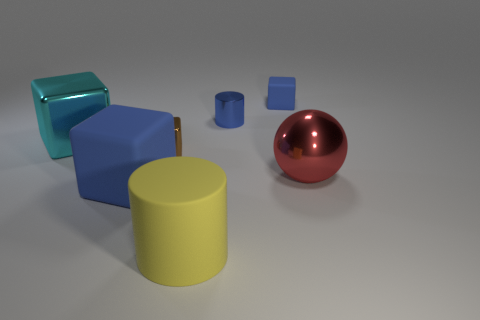Subtract all brown cubes. How many cubes are left? 3 Add 1 small gray blocks. How many objects exist? 8 Subtract all cyan metallic cubes. How many cubes are left? 3 Subtract 0 gray cylinders. How many objects are left? 7 Subtract all balls. How many objects are left? 6 Subtract 1 cylinders. How many cylinders are left? 1 Subtract all brown balls. Subtract all purple cylinders. How many balls are left? 1 Subtract all green cylinders. How many red blocks are left? 0 Subtract all large blue rubber blocks. Subtract all brown cubes. How many objects are left? 5 Add 3 cubes. How many cubes are left? 7 